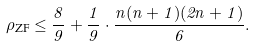<formula> <loc_0><loc_0><loc_500><loc_500>\rho _ { \text {ZF} } \leq \frac { 8 } { 9 } + \frac { 1 } { 9 } \cdot \frac { n ( n + 1 ) ( 2 n + 1 ) } { 6 } .</formula> 